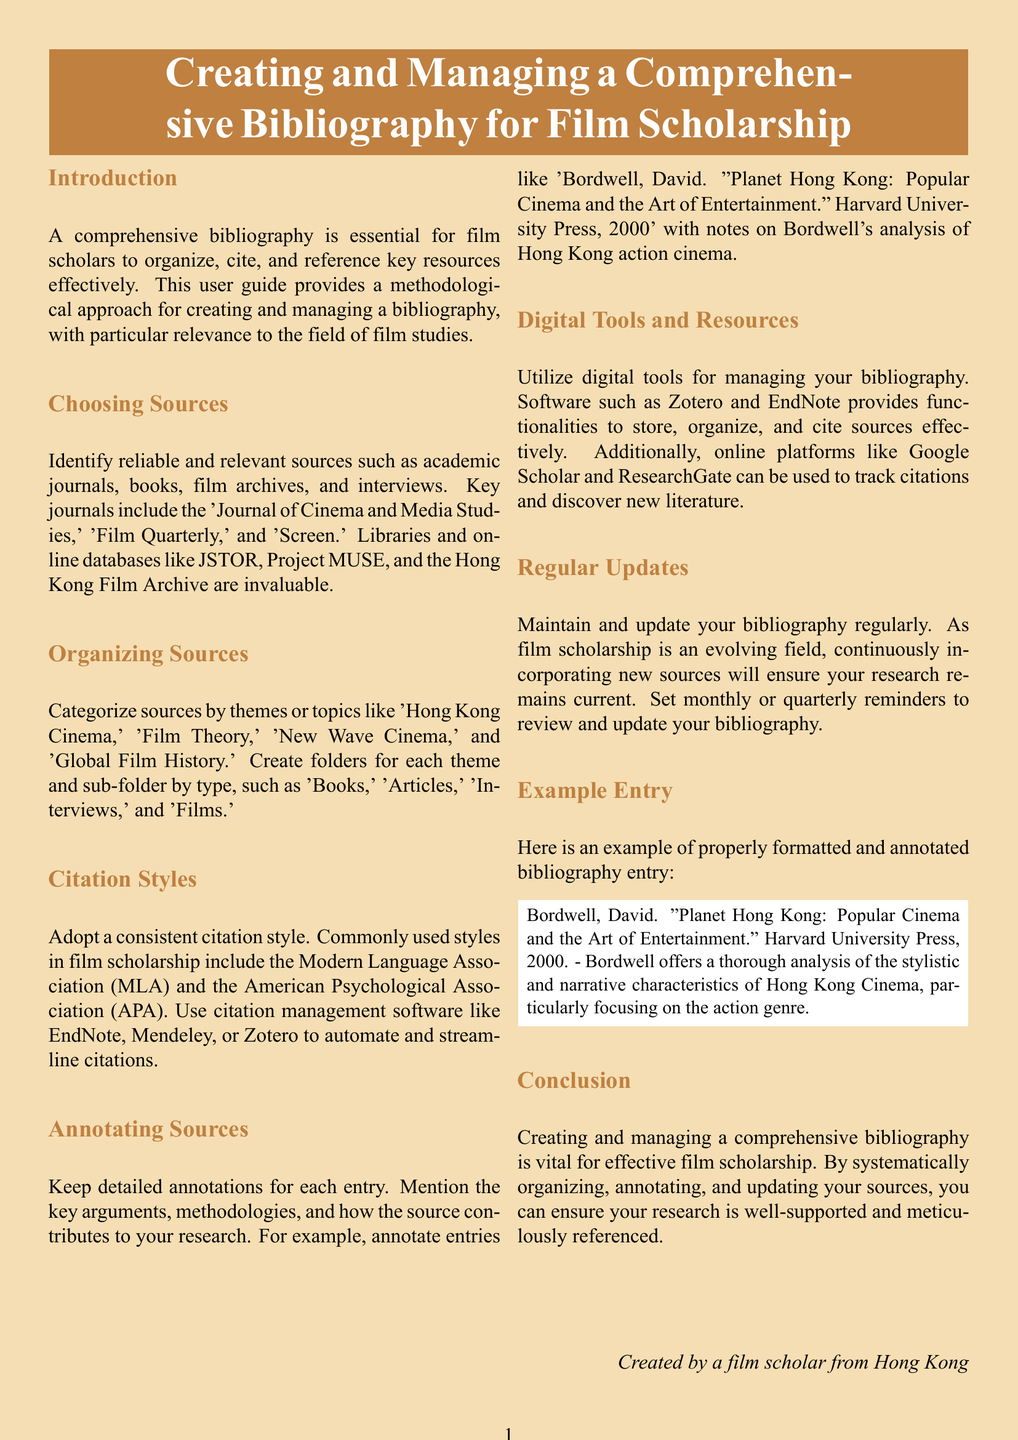What is the primary purpose of a comprehensive bibliography? The primary purpose is to organize, cite, and reference key resources effectively for film scholars.
Answer: Organize, cite, and reference Name one key journal recommended for film scholarship. The user guide suggests several key journals, one of which is the 'Journal of Cinema and Media Studies'.
Answer: Journal of Cinema and Media Studies What citation styles are commonly used in film scholarship? The document mentions the Modern Language Association and the American Psychological Association as commonly used citation styles.
Answer: MLA and APA What should you maintain regarding your bibliography? The guide emphasizes the need to maintain regular updates to the bibliography in order to keep it current.
Answer: Regular updates What is one digital tool recommended for managing bibliographies? Zotero is one of the digital tools mentioned as effective for managing bibliographies.
Answer: Zotero In which section would you find an example bibliography entry? The section titled "Example Entry" contains the example of a properly formatted and annotated bibliography entry.
Answer: Example Entry What is a key action to perform monthly or quarterly according to the guide? The guide recommends setting reminders to review and update your bibliography on a monthly or quarterly basis.
Answer: Review and update Who created the document? The document states that it was created by a film scholar from Hong Kong.
Answer: A film scholar from Hong Kong 